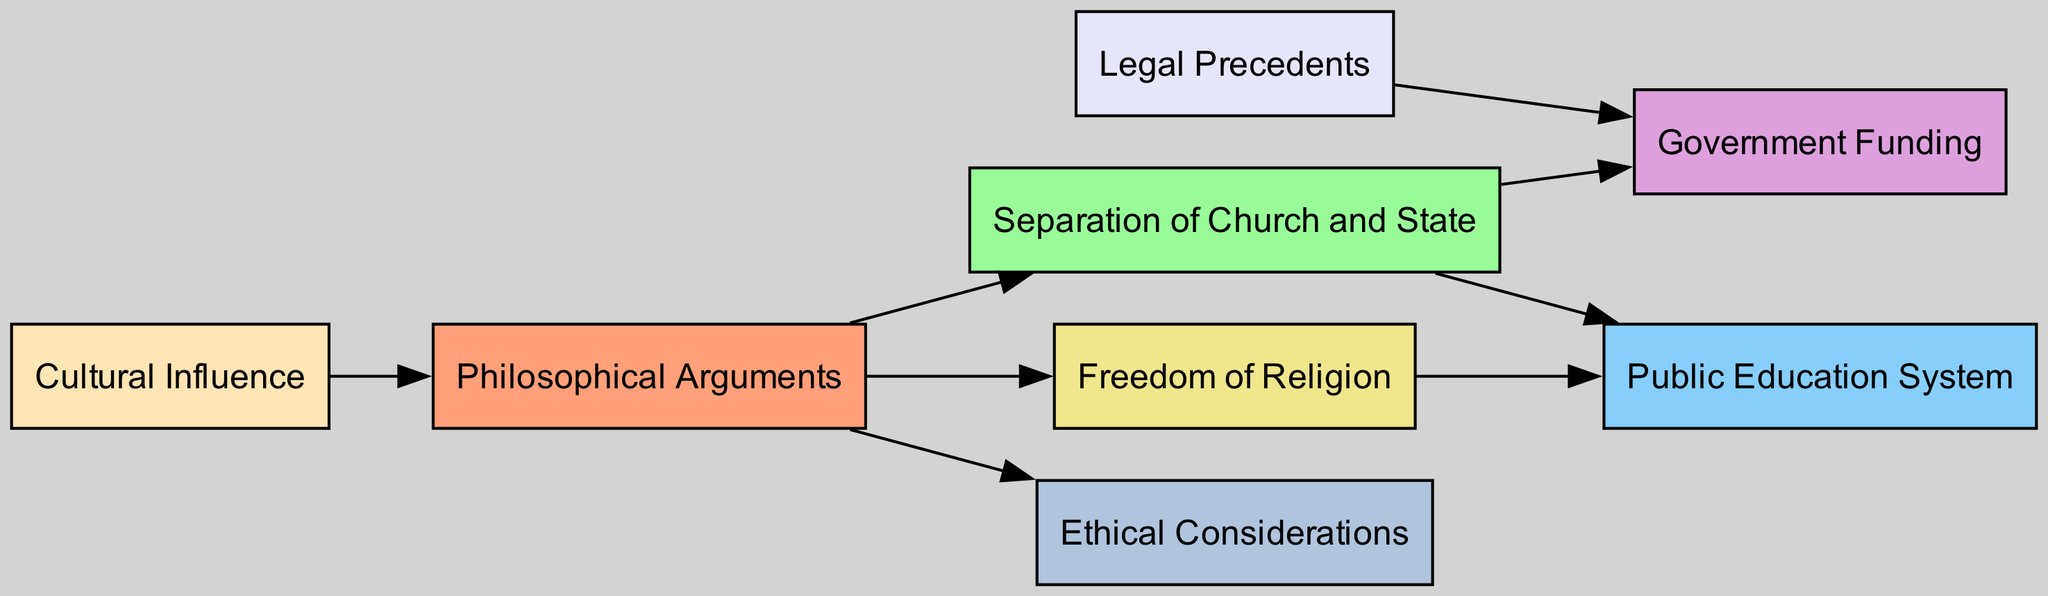What is the total number of nodes in the diagram? To find the total number of nodes, we can count the entries listed in the "nodes" section of the data. There are eight nodes: "Philosophical Arguments", "Separation of Church and State", "Public Education System", "Government Funding", "Freedom of Religion", "Legal Precedents", "Cultural Influence", and "Ethical Considerations".
Answer: 8 Which node directly influences "Government Funding"? To determine which node influences "Government Funding", we can look for edges connecting to it in the "edges" section. There are two sources leading to "Government Funding": "Separation of Church and State" and "Legal Precedents".
Answer: Separation of Church and State, Legal Precedents What is the relationship between "Philosophical Arguments" and "Separation of Church and State"? The relationship is defined through a directed edge. "Philosophical Arguments" points to "Separation of Church and State", indicating that philosophical arguments support or justify the concept of separation between church and state.
Answer: influences Which node has the most edges leading out of it? We need to examine the "edges" section and count outgoing edges for each node. "Philosophical Arguments" has four outgoing edges, connecting to "Separation of Church and State", "Freedom of Religion", "Ethical Considerations", and "Cultural Influence". No other node has more than three outgoing edges.
Answer: Philosophical Arguments How many edges connect to "Public Education System"? By inspecting the "edges" section, we find that "Public Education System" receives edges from two sources: "Separation of Church and State" and "Freedom of Religion". Therefore, it has two incoming edges.
Answer: 2 Which two nodes are directly connected by an edge that also involves the "Freedom of Religion" node? We look for edges involving "Freedom of Religion" in the diagram. The edges lead from "Philosophical Arguments" to "Freedom of Religion" and from "Freedom of Religion" to "Public Education System". This shows that both "Philosophical Arguments" and "Public Education System" are directly connected through "Freedom of Religion".
Answer: Philosophical Arguments, Public Education System What concept connects "Legal Precedents" to "Government Funding"? The connection is made through a direct edge from "Legal Precedents" to "Government Funding", indicating that legal precedents help shape or determine the allocations and rules regarding government funding.
Answer: shapes or determines Which node has a cultural influence on "Philosophical Arguments"? Looking at the "edges" section, we see that "Cultural Influence" has an edge pointing to "Philosophical Arguments". This indicates that it affects or plays a role in shaping philosophical arguments.
Answer: Cultural Influence 